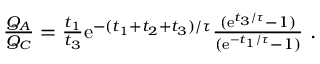Convert formula to latex. <formula><loc_0><loc_0><loc_500><loc_500>\begin{array} { r } { \frac { Q _ { A } } { Q _ { C } } = \frac { t _ { 1 } } { t _ { 3 } } e ^ { - ( t _ { 1 } + t _ { 2 } + t _ { 3 } ) / \tau } \frac { ( e ^ { t _ { 3 } / \tau } - 1 ) } { ( e ^ { - t _ { 1 } / \tau } - 1 ) } . } \end{array}</formula> 